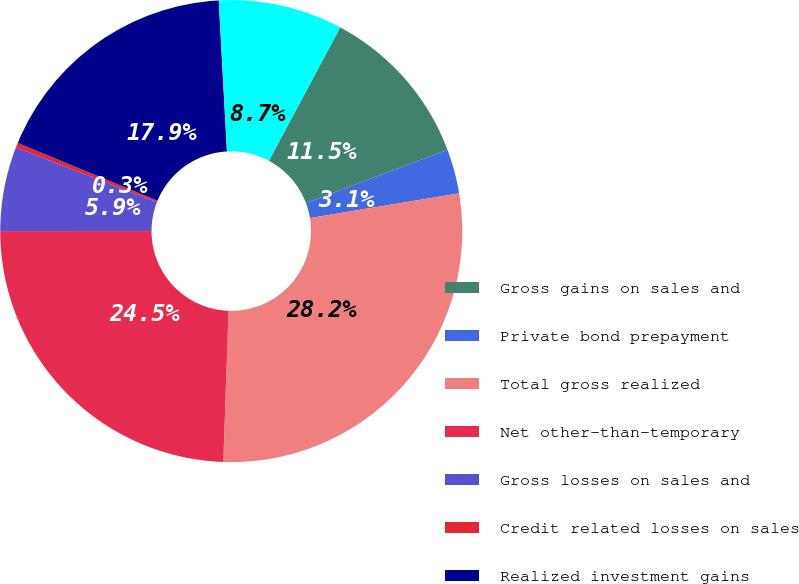<chart> <loc_0><loc_0><loc_500><loc_500><pie_chart><fcel>Gross gains on sales and<fcel>Private bond prepayment<fcel>Total gross realized<fcel>Net other-than-temporary<fcel>Gross losses on sales and<fcel>Credit related losses on sales<fcel>Realized investment gains<fcel>Net gains (losses) on sales<nl><fcel>11.46%<fcel>3.11%<fcel>28.16%<fcel>24.45%<fcel>5.9%<fcel>0.33%<fcel>17.91%<fcel>8.68%<nl></chart> 